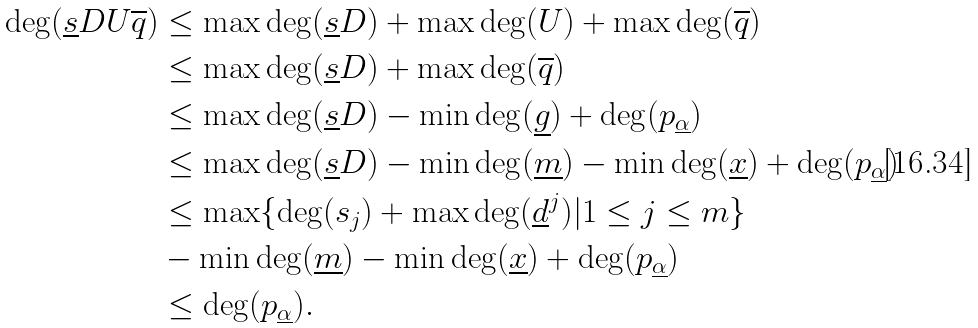Convert formula to latex. <formula><loc_0><loc_0><loc_500><loc_500>\deg ( \underline { s } D U \overline { q } ) & \leq \max \deg ( \underline { s } D ) + \max \deg ( U ) + \max \deg ( \overline { q } ) \\ & \leq \max \deg ( \underline { s } D ) + \max \deg ( \overline { q } ) \\ & \leq \max \deg ( \underline { s } D ) - \min \deg ( \underline { g } ) + \deg ( p _ { \underline { \alpha } } ) \\ & \leq \max \deg ( \underline { s } D ) - \min \deg ( \underline { m } ) - \min \deg ( \underline { x } ) + \deg ( p _ { \underline { \alpha } } ) \\ & \leq \max \{ \deg ( s _ { j } ) + \max \deg ( \underline { d } ^ { j } ) | 1 \leq j \leq m \} \\ & - \min \deg ( \underline { m } ) - \min \deg ( \underline { x } ) + \deg ( p _ { \underline { \alpha } } ) \\ & \leq \deg ( p _ { \underline { \alpha } } ) .</formula> 